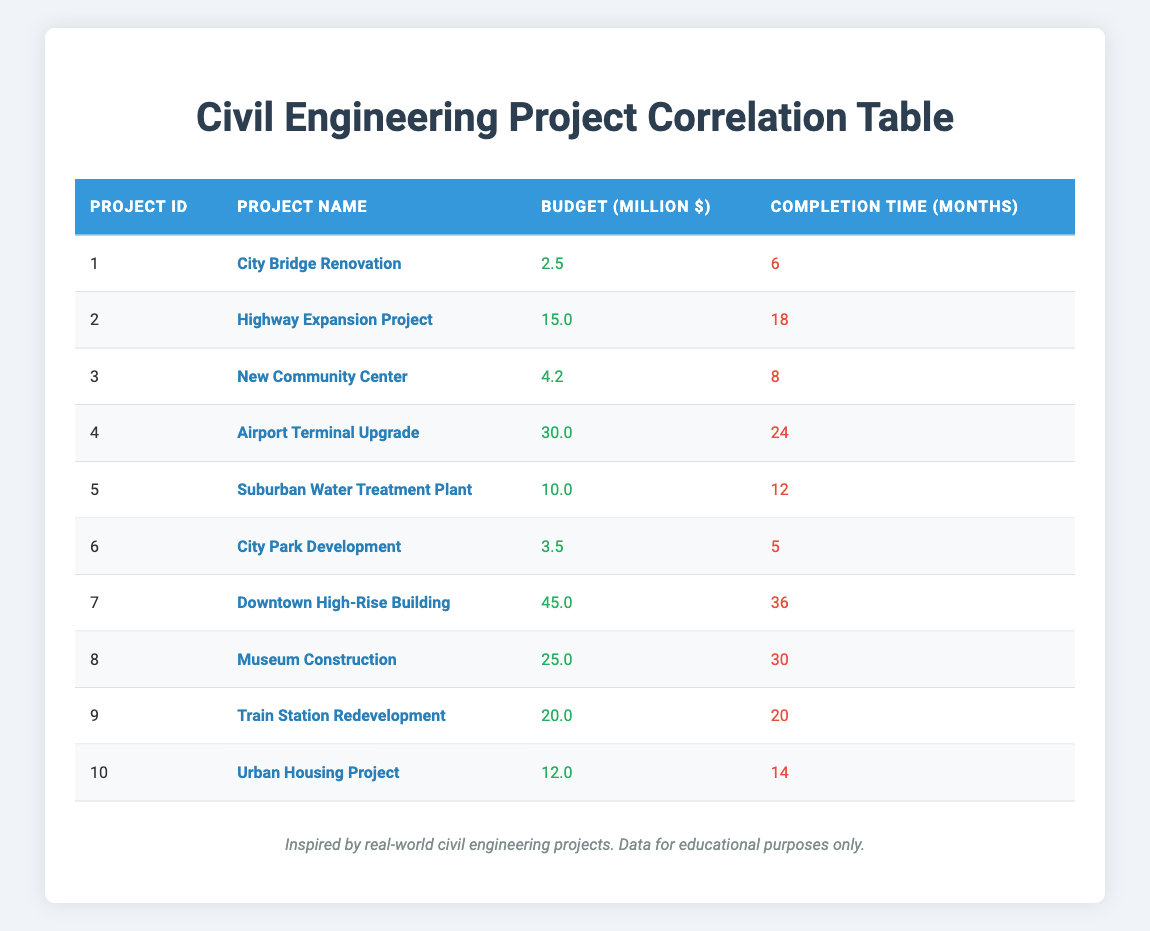What is the budget for the Airport Terminal Upgrade project? The table shows the budget for the Airport Terminal Upgrade project listed under the "Budget (Million $)" column. For project ID 4, the budget is 30.0 million dollars.
Answer: 30.0 million Which project has the longest completion time? To find this, we look for the maximum value in the "Completion Time (Months)" column. The Downtown High-Rise Building, listed under project ID 7, takes the longest with 36 months.
Answer: Downtown High-Rise Building What is the average budget of all the projects? The total budget of all projects is (2.5 + 15 + 4.2 + 30 + 10 + 3.5 + 45 + 25 + 20 + 12) = 172.2 million. There are 10 projects, so the average budget is 172.2 / 10 = 17.22 million.
Answer: 17.22 million Is it true that the New Community Center project has a budget greater than 5 million? Looking at the New Community Center project (project ID 3), the budget is 4.2 million, which is less than 5 million. Therefore, the statement is false.
Answer: False How many projects have a completion time of more than 20 months? We check the "Completion Time (Months)" column for values greater than 20. The Airport Terminal Upgrade (24 months), Downtown High-Rise Building (36 months), and Museum Construction (30 months) all exceed 20 months. This totals to 3 projects.
Answer: 3 What is the completion time for the Suburban Water Treatment Plant? By locating the Suburban Water Treatment Plant in the table, which corresponds to project ID 5, we find its completion time listed in the respective column as 12 months.
Answer: 12 months Do any projects have a budget less than 5 million? In the table, we examine the "Budget (Million $)" column for values less than 5 million. The City Bridge Renovation (2.5 million) and City Park Development (3.5 million) fit this criterion. This indicates there are projects with budgets less than 5 million, making the statement true.
Answer: True Which project has the highest budget, and what is its budget? We look for the maximum value in the "Budget (Million $)" column. The Downtown High-Rise Building has the highest budget of 45 million dollars.
Answer: Downtown High-Rise Building, 45 million What is the difference in completion time between the project with the highest and lowest budget? The project with the highest budget is Downtown High-Rise Building (45 million), which takes 36 months. The project with the lowest budget is City Bridge Renovation (2.5 million), which takes 6 months. The difference is 36 - 6 = 30 months.
Answer: 30 months 